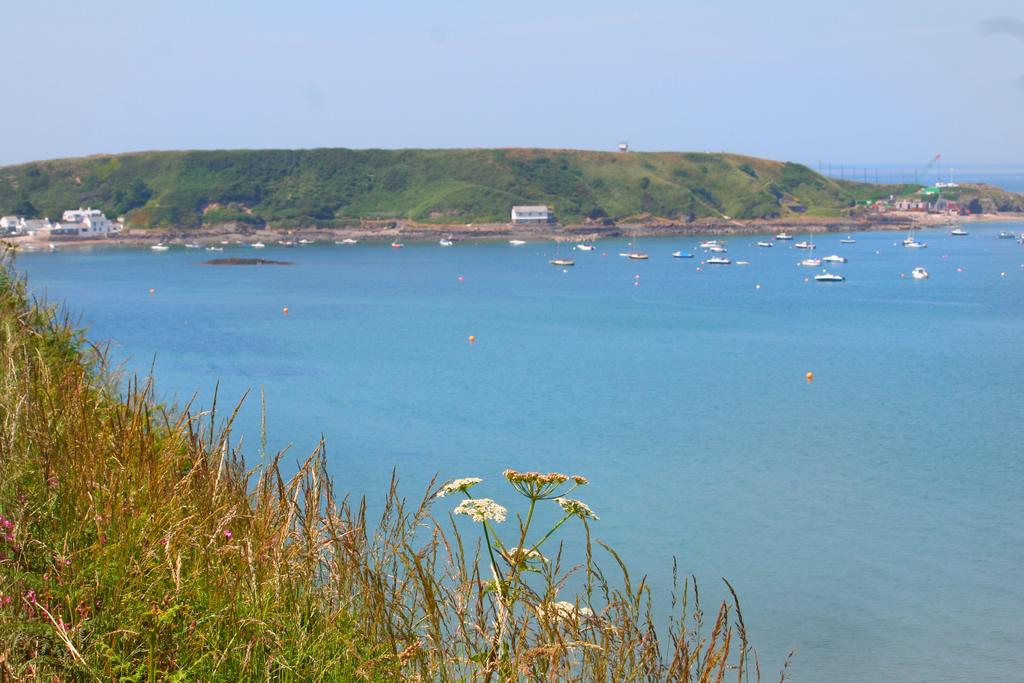What type of vegetation is in the front of the image? There is grass in the front of the image. What body of water is visible in the image? There is an ocean in the back of the image. What can be seen floating in the ocean? There are ships in the ocean. What structures are on the left side of the image? There are buildings on the left side of the image. What is the location of the buildings in relation to the hill? The buildings are in front of a hill. What is visible above the hill? The sky is visible above the hill. How many pizzas are being served at the meeting in the image? There is no meeting or pizzas present in the image. What type of regret is expressed by the person in the image? There is no person expressing regret in the image. 